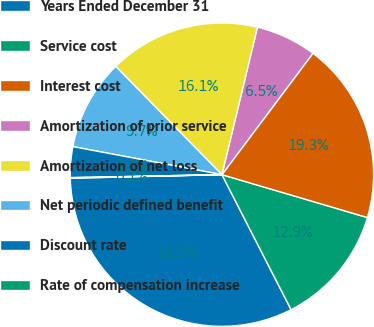Convert chart to OTSL. <chart><loc_0><loc_0><loc_500><loc_500><pie_chart><fcel>Years Ended December 31<fcel>Service cost<fcel>Interest cost<fcel>Amortization of prior service<fcel>Amortization of net loss<fcel>Net periodic defined benefit<fcel>Discount rate<fcel>Rate of compensation increase<nl><fcel>32.16%<fcel>12.9%<fcel>19.32%<fcel>6.48%<fcel>16.11%<fcel>9.69%<fcel>3.27%<fcel>0.06%<nl></chart> 